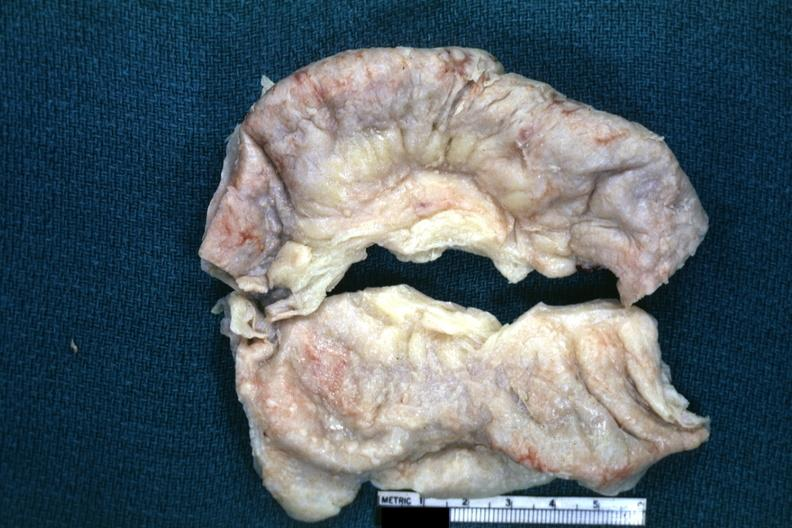does this image show fixed tissue typical appearance of tuberculous peritonitis except for color being off a bit?
Answer the question using a single word or phrase. Yes 